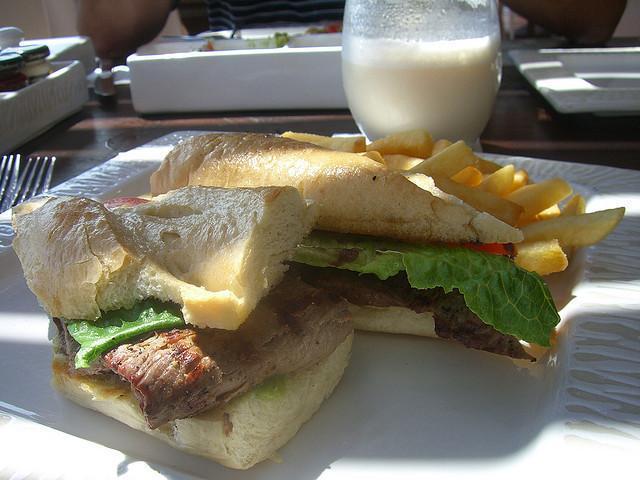How many sandwiches can you see?
Give a very brief answer. 2. How many little bears are shown?
Give a very brief answer. 0. 